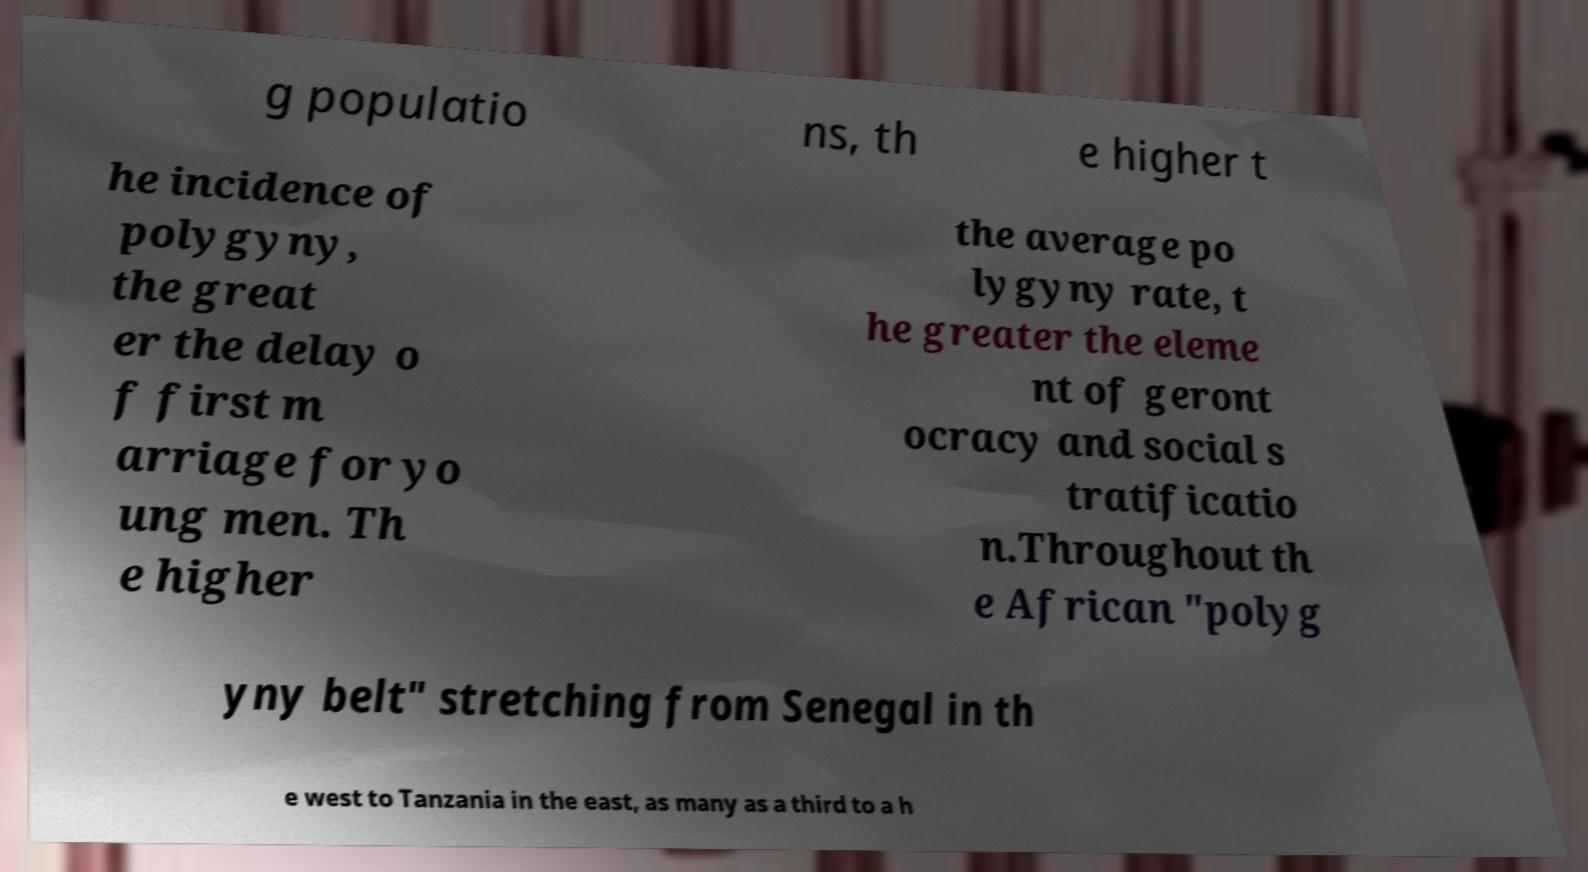For documentation purposes, I need the text within this image transcribed. Could you provide that? g populatio ns, th e higher t he incidence of polygyny, the great er the delay o f first m arriage for yo ung men. Th e higher the average po lygyny rate, t he greater the eleme nt of geront ocracy and social s tratificatio n.Throughout th e African "polyg yny belt" stretching from Senegal in th e west to Tanzania in the east, as many as a third to a h 